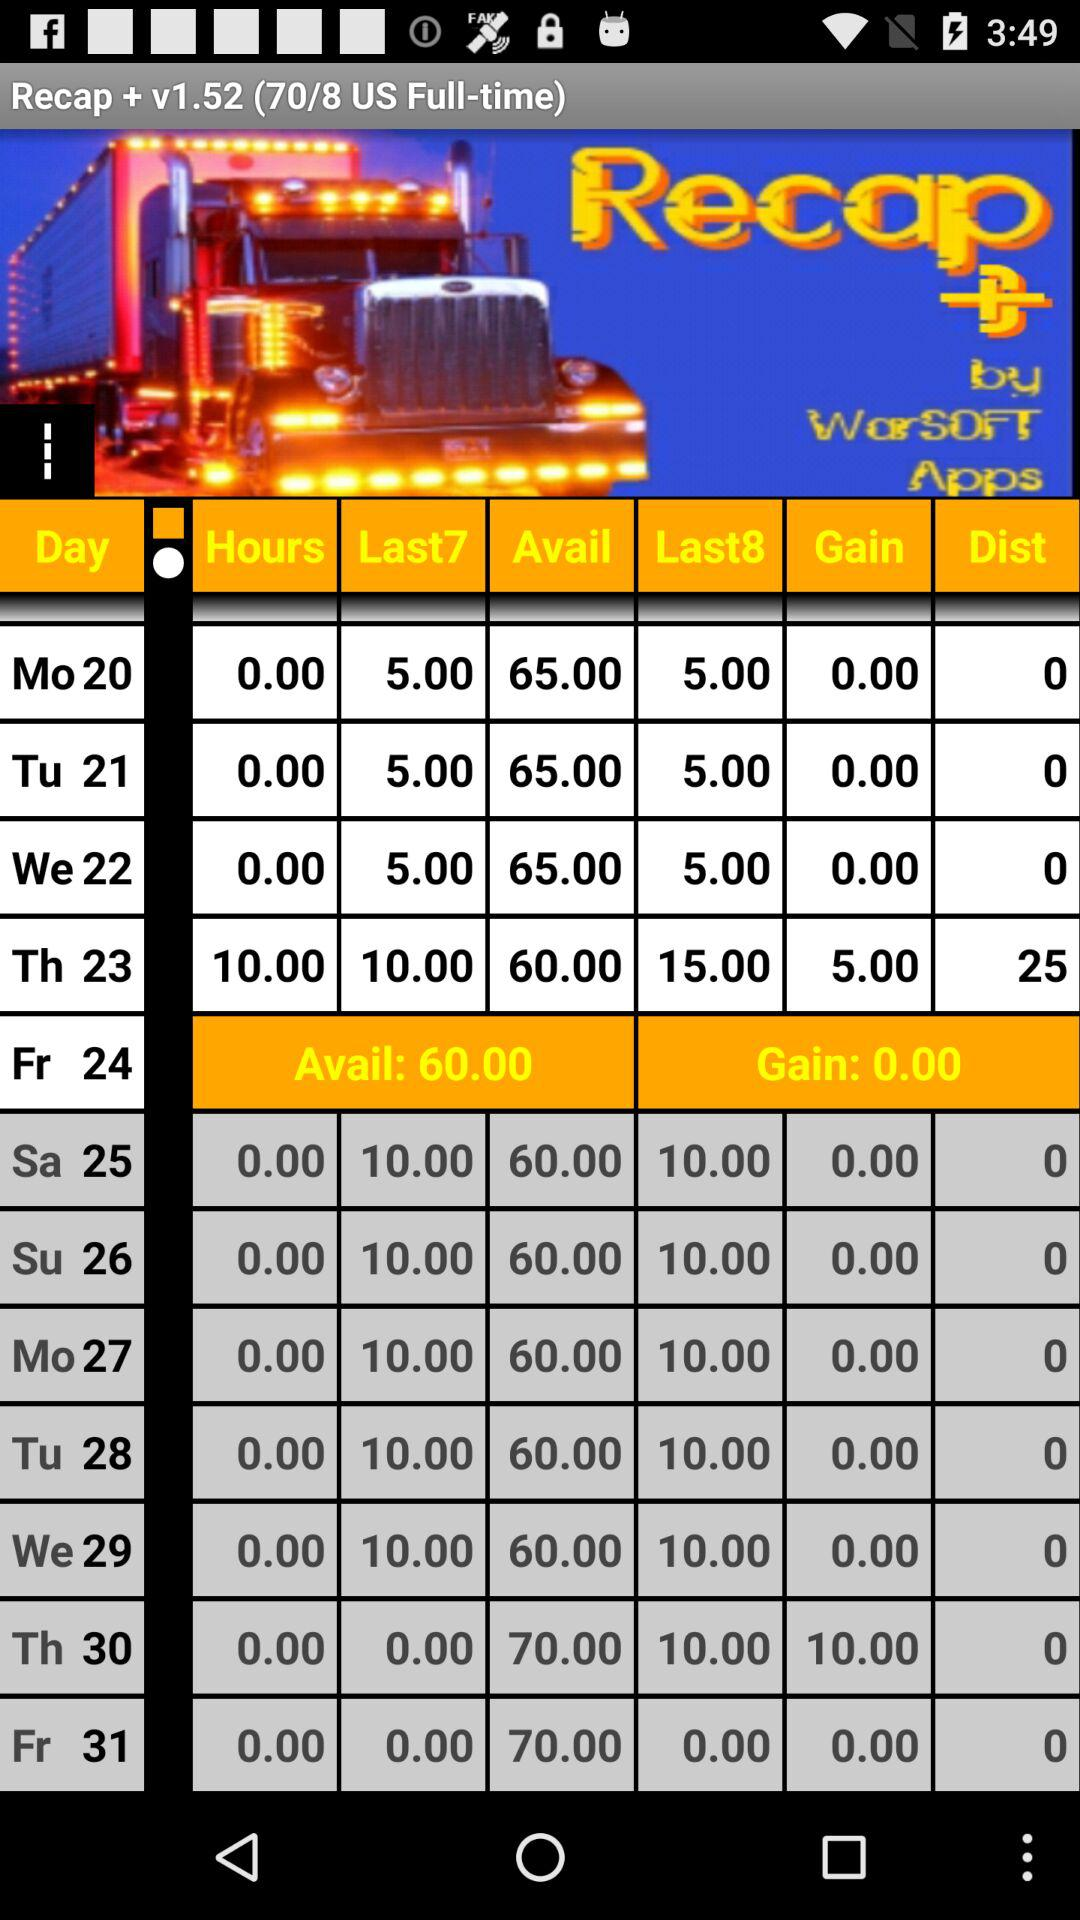What is the version of "Recap +"? The version of "Recap +" is 1.52. 